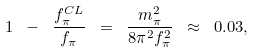<formula> <loc_0><loc_0><loc_500><loc_500>1 \ - \ \frac { f ^ { C L } _ { \pi } } { f _ { \pi } } \ = \ \frac { m ^ { 2 } _ { \pi } } { 8 \pi ^ { 2 } f ^ { 2 } _ { \pi } } \ \approx \ 0 . 0 3 ,</formula> 